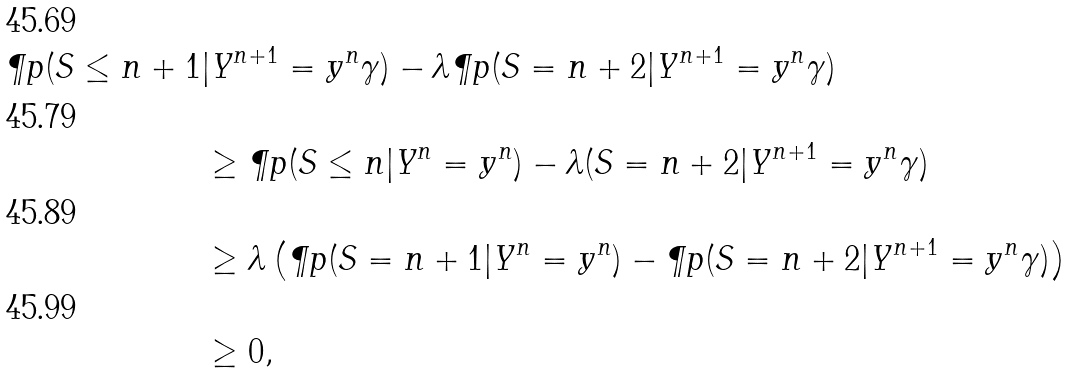Convert formula to latex. <formula><loc_0><loc_0><loc_500><loc_500>\P p ( S \leq n + 1 & | Y ^ { n + 1 } = y ^ { n } \gamma ) - \lambda \P p ( S = n + 2 | Y ^ { n + 1 } = y ^ { n } \gamma ) \\ & \geq \P p ( S \leq n | Y ^ { n } = y ^ { n } ) - \lambda ( S = n + 2 | Y ^ { n + 1 } = y ^ { n } \gamma ) \\ & \geq \lambda \left ( \P p ( S = n + 1 | Y ^ { n } = y ^ { n } ) - \P p ( S = n + 2 | Y ^ { n + 1 } = y ^ { n } \gamma ) \right ) \\ & \geq 0 ,</formula> 